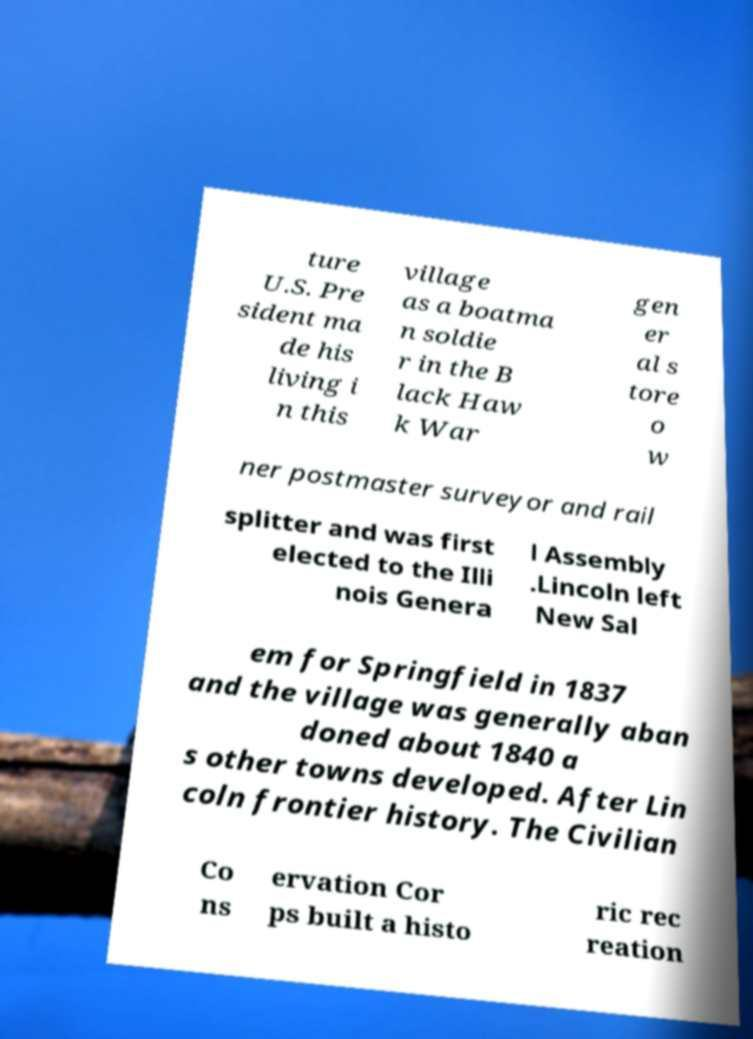Can you accurately transcribe the text from the provided image for me? ture U.S. Pre sident ma de his living i n this village as a boatma n soldie r in the B lack Haw k War gen er al s tore o w ner postmaster surveyor and rail splitter and was first elected to the Illi nois Genera l Assembly .Lincoln left New Sal em for Springfield in 1837 and the village was generally aban doned about 1840 a s other towns developed. After Lin coln frontier history. The Civilian Co ns ervation Cor ps built a histo ric rec reation 